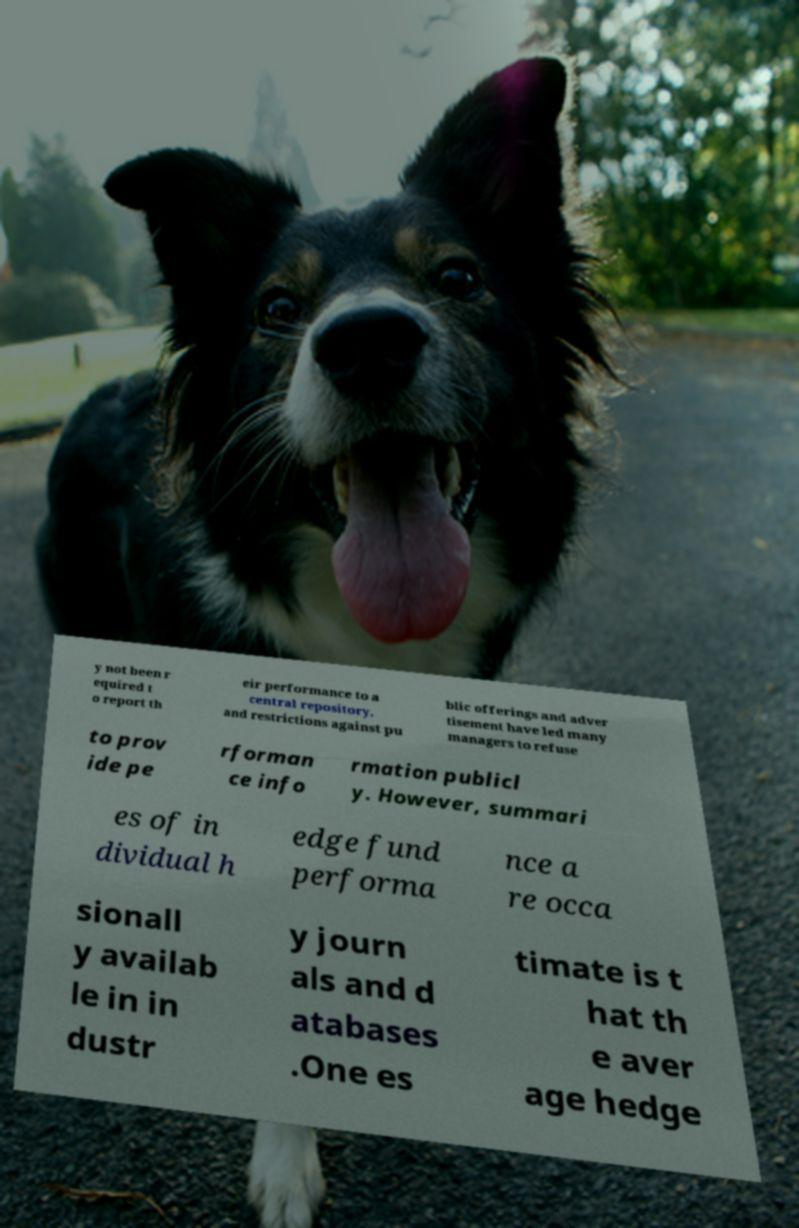Please read and relay the text visible in this image. What does it say? y not been r equired t o report th eir performance to a central repository, and restrictions against pu blic offerings and adver tisement have led many managers to refuse to prov ide pe rforman ce info rmation publicl y. However, summari es of in dividual h edge fund performa nce a re occa sionall y availab le in in dustr y journ als and d atabases .One es timate is t hat th e aver age hedge 